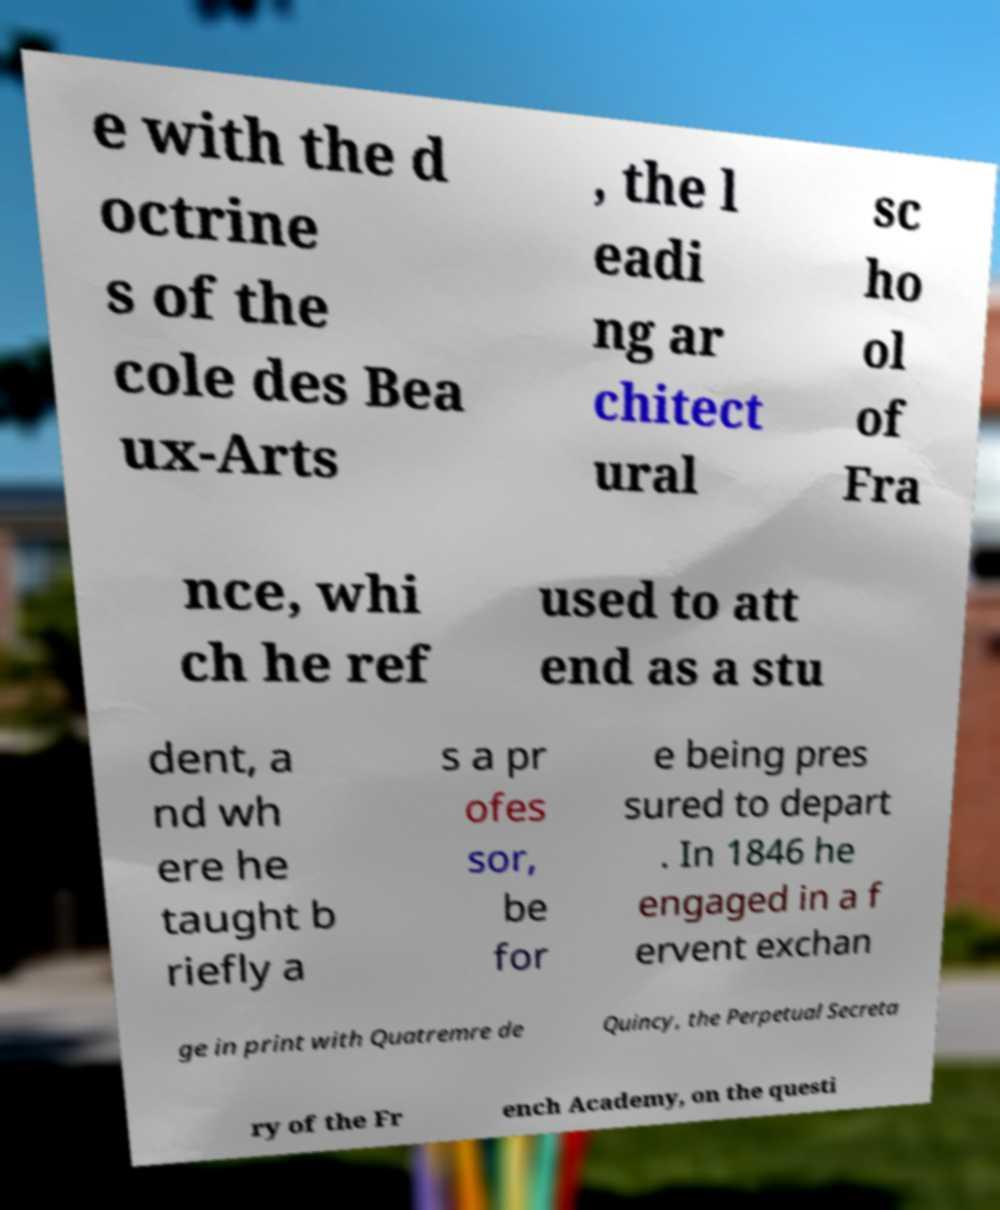Could you extract and type out the text from this image? e with the d octrine s of the cole des Bea ux-Arts , the l eadi ng ar chitect ural sc ho ol of Fra nce, whi ch he ref used to att end as a stu dent, a nd wh ere he taught b riefly a s a pr ofes sor, be for e being pres sured to depart . In 1846 he engaged in a f ervent exchan ge in print with Quatremre de Quincy, the Perpetual Secreta ry of the Fr ench Academy, on the questi 